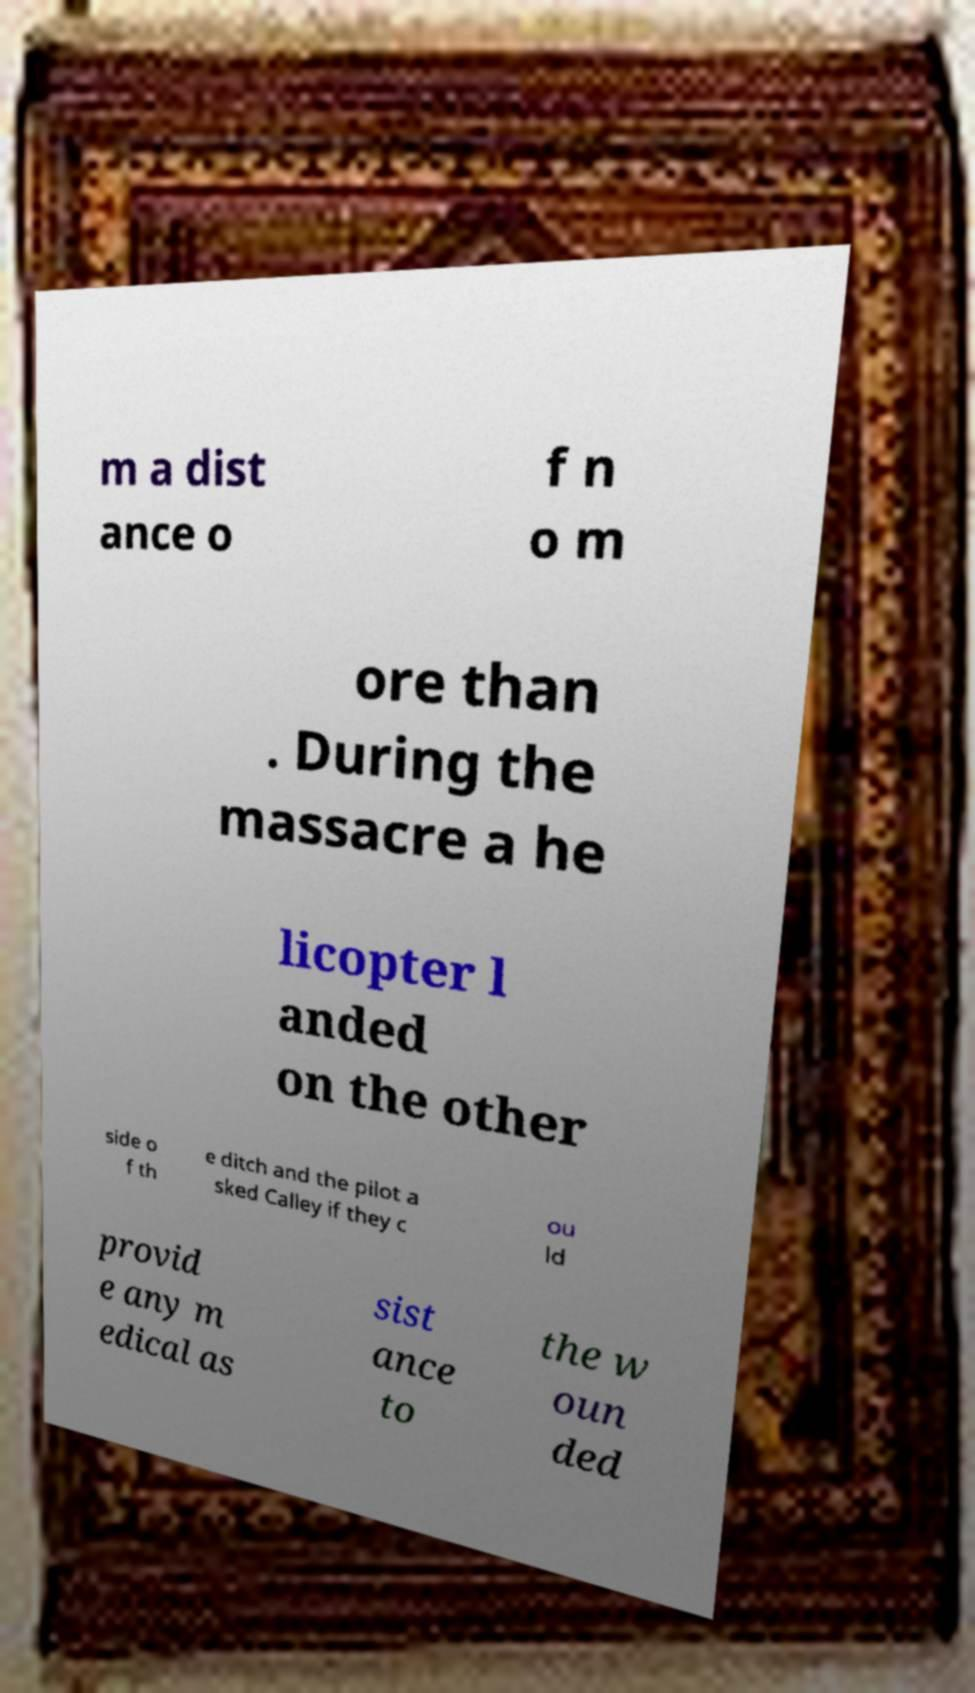What messages or text are displayed in this image? I need them in a readable, typed format. m a dist ance o f n o m ore than . During the massacre a he licopter l anded on the other side o f th e ditch and the pilot a sked Calley if they c ou ld provid e any m edical as sist ance to the w oun ded 